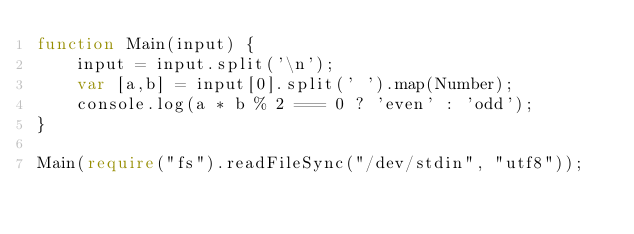<code> <loc_0><loc_0><loc_500><loc_500><_TypeScript_>function Main(input) {
    input = input.split('\n');
    var [a,b] = input[0].split(' ').map(Number);
    console.log(a * b % 2 === 0 ? 'even' : 'odd');
}

Main(require("fs").readFileSync("/dev/stdin", "utf8"));</code> 